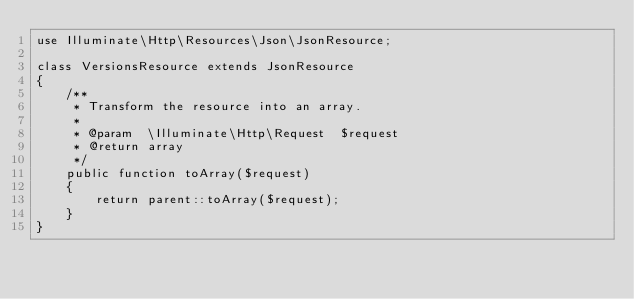Convert code to text. <code><loc_0><loc_0><loc_500><loc_500><_PHP_>use Illuminate\Http\Resources\Json\JsonResource;

class VersionsResource extends JsonResource
{
    /**
     * Transform the resource into an array.
     *
     * @param  \Illuminate\Http\Request  $request
     * @return array
     */
    public function toArray($request)
    {
        return parent::toArray($request);
    }
}
</code> 